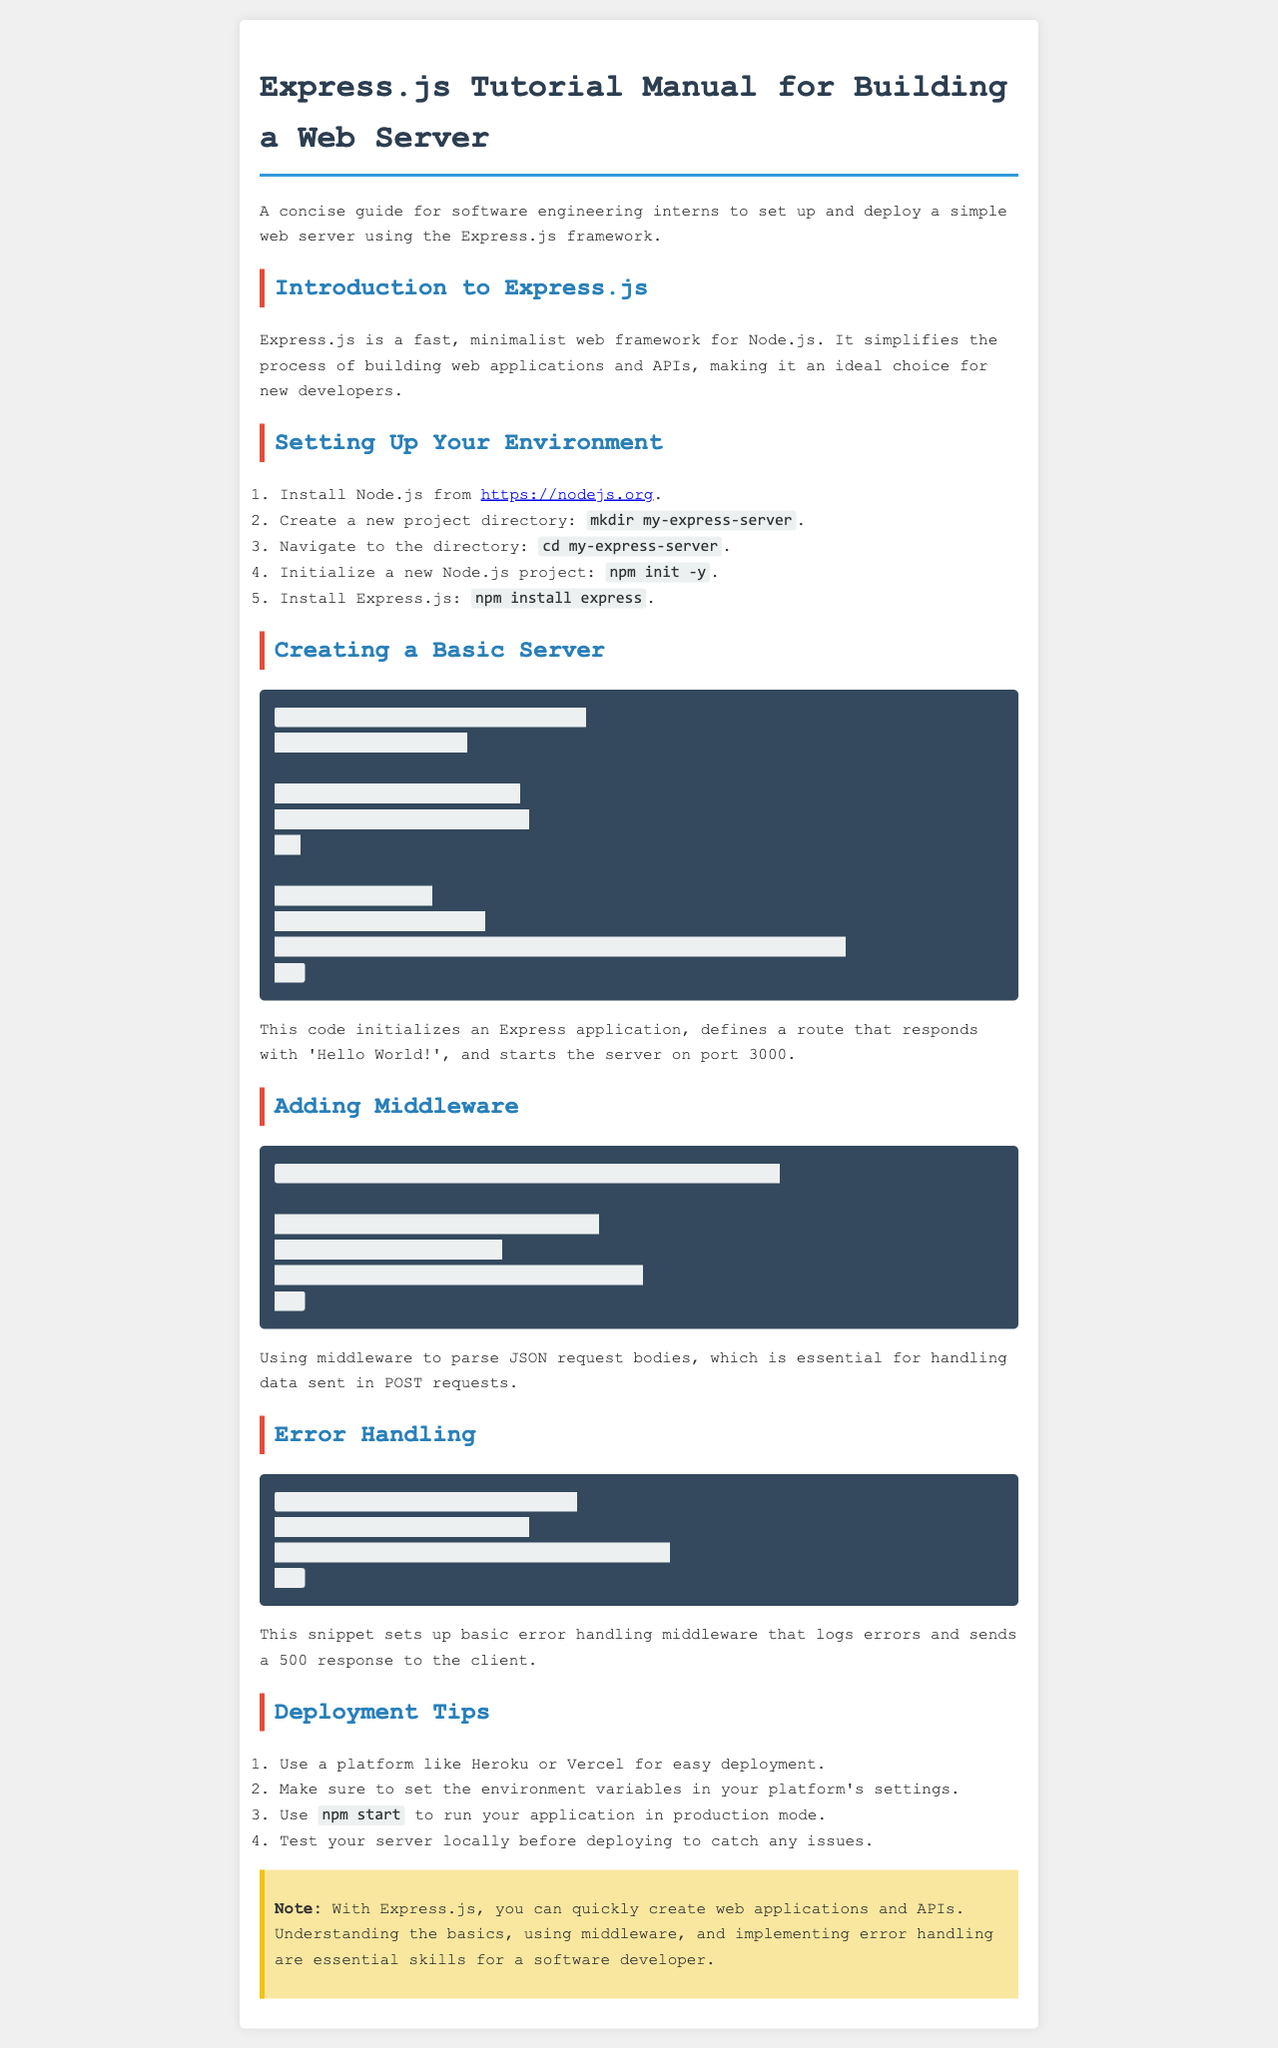What is the title of the manual? The title of the manual is clearly stated at the beginning as “Express.js Tutorial Manual for Building a Web Server”.
Answer: Express.js Tutorial Manual for Building a Web Server What is the first step in setting up your environment? The document outlines the first step as “Install Node.js from https://nodejs.org”.
Answer: Install Node.js from https://nodejs.org What is the port number used in the basic server code? The port number where the server listens is specified in the code snippet as “const PORT = 3000”.
Answer: 3000 Which method is used to parse incoming JSON requests? The method mentioned for this purpose in the document is “express.json()”.
Answer: express.json() What is the purpose of the error handling middleware? The document describes that the error handling middleware logs errors and sends a 500 response to the client.
Answer: Logs errors and sends a 500 response Which deployment platforms are suggested in the manual? The manual suggests using platforms like "Heroku or Vercel" for easy deployment.
Answer: Heroku or Vercel 